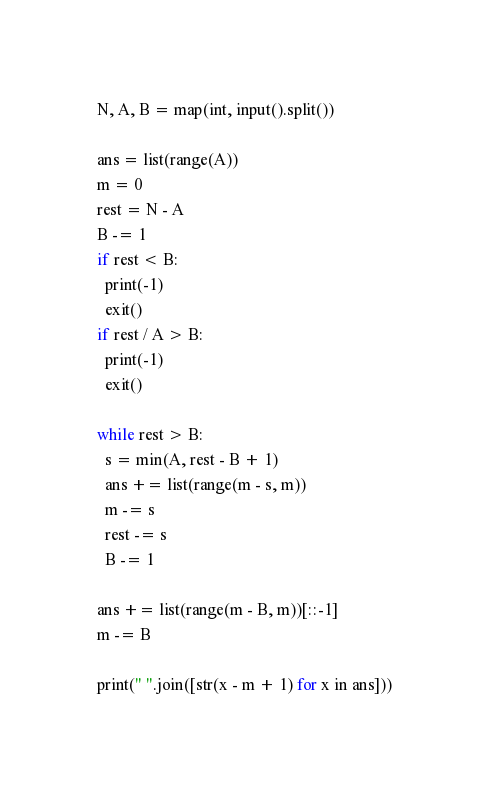Convert code to text. <code><loc_0><loc_0><loc_500><loc_500><_Python_>N, A, B = map(int, input().split())

ans = list(range(A))
m = 0
rest = N - A
B -= 1
if rest < B:
  print(-1)
  exit()
if rest / A > B:
  print(-1)
  exit()

while rest > B:
  s = min(A, rest - B + 1)
  ans += list(range(m - s, m))
  m -= s
  rest -= s
  B -= 1

ans += list(range(m - B, m))[::-1]
m -= B

print(" ".join([str(x - m + 1) for x in ans]))
</code> 